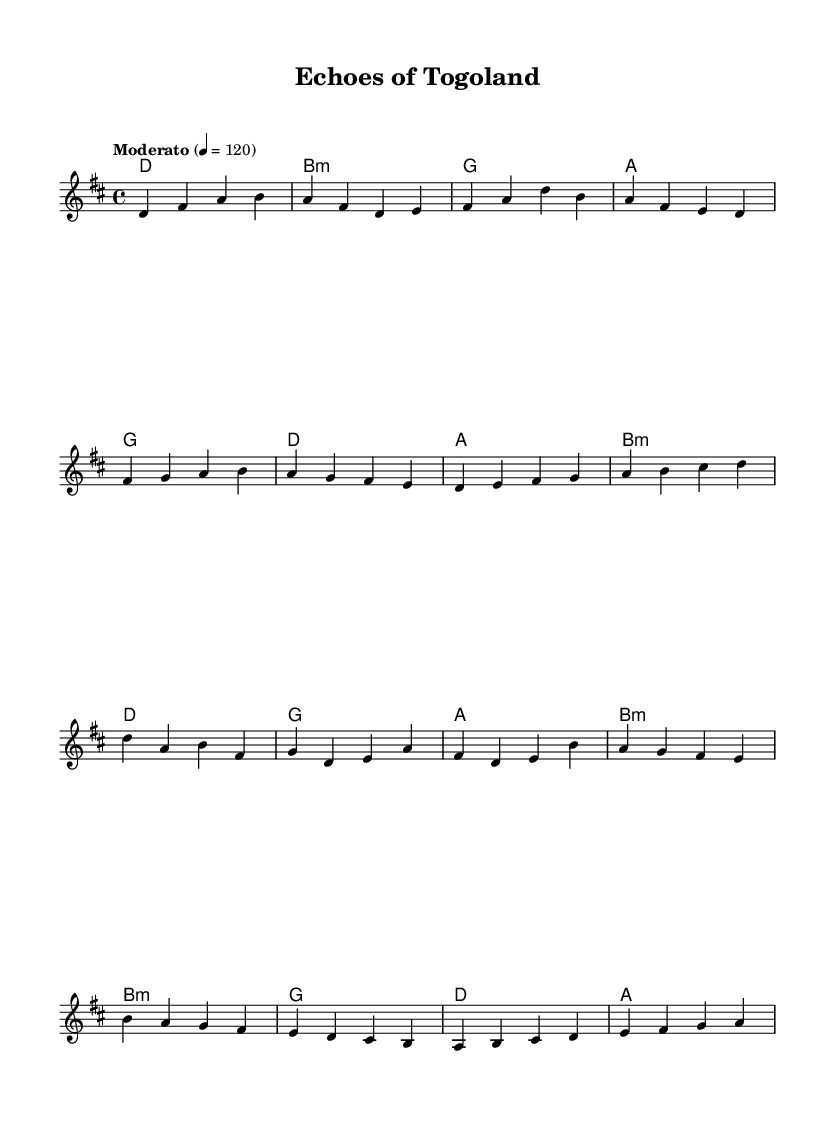What is the key signature of this music? The key signature is indicated at the beginning of the piece and is marked with two sharps, which corresponds to D major.
Answer: D major What is the time signature? The time signature is located right after the clef and key signature, showing the number of beats per measure and the type of note that receives one beat. It is written as 4/4.
Answer: 4/4 What is the tempo marking of the piece? The tempo marking appears above the staff in text format, indicating the speed at which the music should be played. It reads "Moderato," followed by a metronome marking of 120.
Answer: Moderato How many measures are there in the verse section? By counting the sections specifically labeled "Verse" in the provided sheet music, it is revealed there are four measures.
Answer: 4 Which section has a different chord quality in the bridge compared to the verse? By examining the chord symbols under each section, it is clear that the verse has mostly major chords while the bridge features a minor chord (b:m).
Answer: b:m What musical structure is commonly found in K-Pop songs that is evidenced in this piece? The piece includes a clear structure divided into sections such as Verse, Pre-Chorus, Chorus, and Bridge, which is typical of K-Pop songs for storytelling and engagement.
Answer: Verse, Pre-Chorus, Chorus, Bridge 